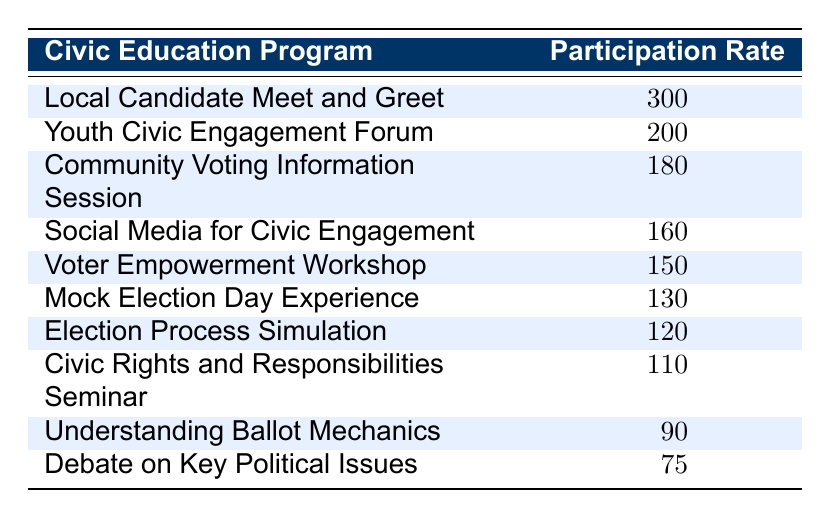What program had the highest participation rate? The participation rates for each program are listed, and the "Local Candidate Meet and Greet" has the highest rate at 300.
Answer: Local Candidate Meet and Greet What is the participation rate for the "Understanding Ballot Mechanics" program? The table specifically shows that the participation rate for "Understanding Ballot Mechanics" is 90.
Answer: 90 How many programs had a participation rate of over 150? Looking at the participation rates, the programs with rates over 150 are "Local Candidate Meet and Greet" (300), "Youth Civic Engagement Forum" (200), "Community Voting Information Session" (180), and "Social Media for Civic Engagement" (160). This gives a total of 4 programs.
Answer: 4 What is the average participation rate for all programs? To find the average, sum all participation rates: (300 + 200 + 180 + 160 + 150 + 130 + 120 + 110 + 90 + 75) = 1,615. Divide by the number of programs, which is 10. Thus, the average is 1,615 / 10 = 161.5.
Answer: 161.5 Is the participation rate for the "Mock Election Day Experience" higher than the "Election Process Simulation"? The table indicates that "Mock Election Day Experience" has a participation rate of 130, while "Election Process Simulation" has a rate of 120. Therefore, yes, 130 is greater than 120.
Answer: Yes How much higher is the "Community Voting Information Session" participation rate compared to the "Debate on Key Political Issues"? The "Community Voting Information Session" has a participation rate of 180, and the "Debate on Key Political Issues" has a rate of 75. The difference is 180 - 75 = 105.
Answer: 105 Which program has the lowest participation rate? In the table, the program with the lowest participation rate is "Debate on Key Political Issues," which has a rate of 75.
Answer: Debate on Key Political Issues Are there more programs with participation rates below 100 or above 100? The programs below 100 are "Understanding Ballot Mechanics" (90) and "Debate on Key Political Issues" (75), totaling 2. The programs above 100 are "Local Candidate Meet and Greet" (300), "Youth Civic Engagement Forum" (200), "Community Voting Information Session" (180), "Social Media for Civic Engagement" (160), "Voter Empowerment Workshop" (150), "Mock Election Day Experience" (130), "Election Process Simulation" (120), and "Civic Rights and Responsibilities Seminar" (110), totaling 8. Thus, there are more programs above 100.
Answer: More programs are above 100 How many more participants attended the "Youth Civic Engagement Forum" compared to the "Debate on Key Political Issues"? The participation rate for the "Youth Civic Engagement Forum" is 200, and for the "Debate on Key Political Issues" it is 75. The difference is 200 - 75 = 125.
Answer: 125 